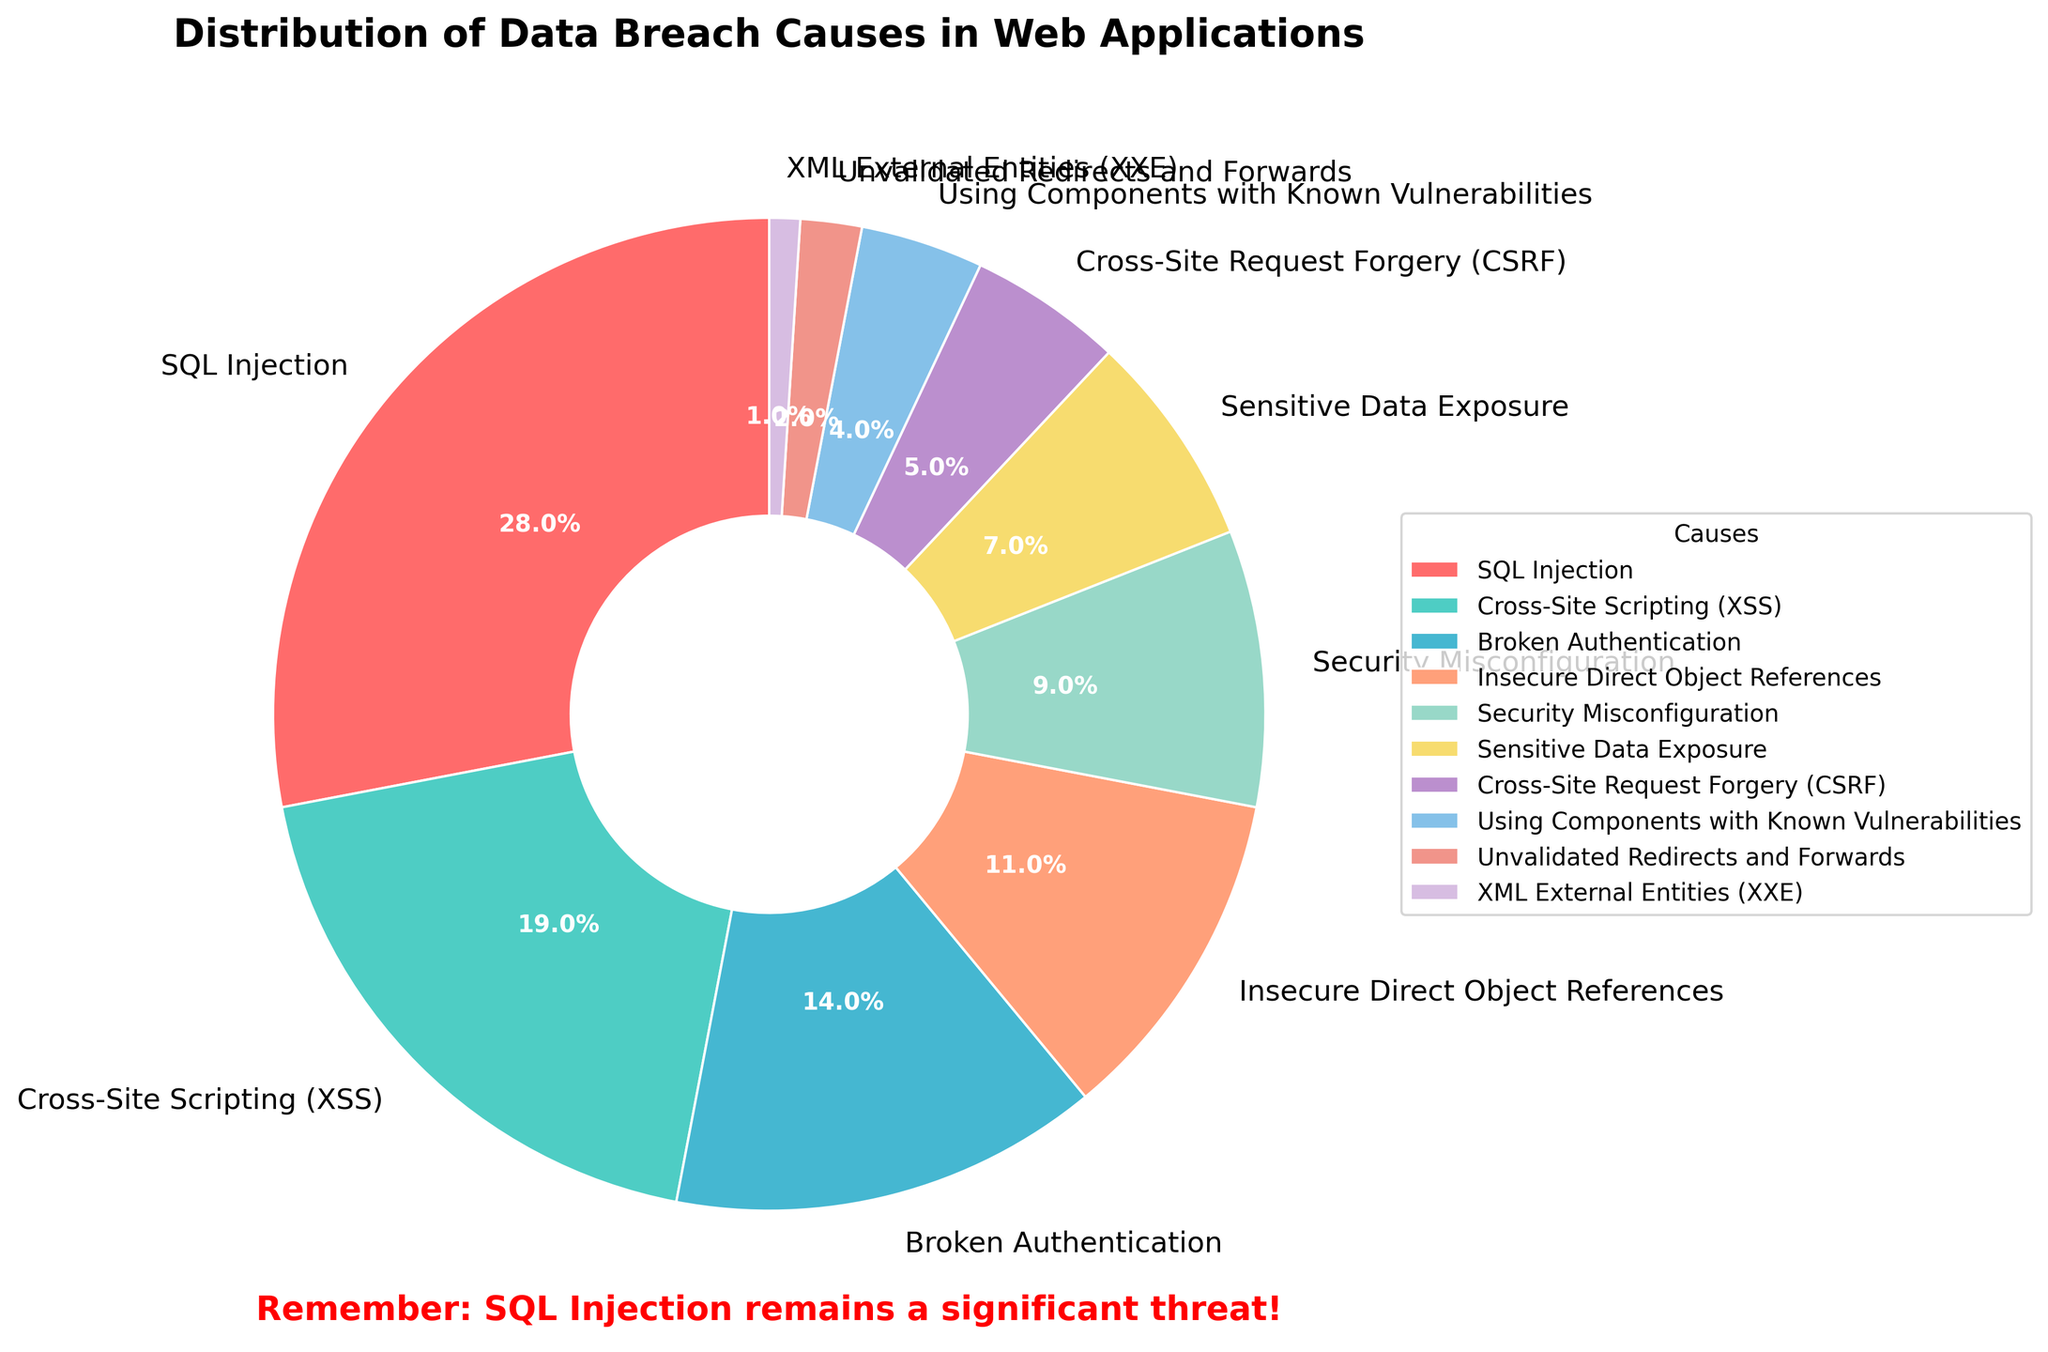Which cause has the largest percentage in the distribution? The pie chart shows the distribution of causes, and the largest wedge represents SQL Injection. The corresponding percentage is also displayed.
Answer: SQL Injection What is the combined percentage of Cross-Site Scripting (XSS) and Broken Authentication? To find the combined percentage, add the percentages of Cross-Site Scripting (19%) and Broken Authentication (14%).
Answer: 33% Rank the top three causes of data breaches. By comparing the sizes of the wedges and their percentages, the top three causes in descending order are SQL Injection (28%), Cross-Site Scripting (19%), and Broken Authentication (14%).
Answer: SQL Injection, Cross-Site Scripting, Broken Authentication How many causes have a percentage greater than or equal to 10%? Check each percentage and count the causes with values 10% or higher: SQL Injection (28%), Cross-Site Scripting (19%), Broken Authentication (14%), Insecure Direct Object References (11%).
Answer: 4 Which cause has the smallest percentage? The smallest wedge, labeled "XML External Entities (XXE)," has a percentage of 1%.
Answer: XML External Entities (XXE) What is the difference in percentage between Security Misconfiguration and Sensitive Data Exposure? Subtract the percentage of Sensitive Data Exposure (7%) from Security Misconfiguration (9%).
Answer: 2% Which causes have similar percentages? By examining the values, Sensitive Data Exposure (7%) and Cross-Site Request Forgery (CSRF) (5%) have close percentages.
Answer: Sensitive Data Exposure and Cross-Site Request Forgery If you sum up the percentages of Security Misconfiguration, Sensitive Data Exposure, and Cross-Site Request Forgery (CSRF), what is the total? Add the percentages: Security Misconfiguration (9%) + Sensitive Data Exposure (7%) + Cross-Site Request Forgery (CSRF) (5%).
Answer: 21% What colors represent SQL Injection and Cross-Site Scripting (XSS)? The pie chart uses specific colors for each cause. SQL Injection is represented by a red color, and Cross-Site Scripting (XSS) by a teal color.
Answer: Red and Teal How does the distribution emphasize the risk of SQL Injection? The pie chart includes a subtitle emphasizing the threat of SQL Injection, and SQL Injection has the largest wedge and percentage.
Answer: It highlights SQL Injection's dominance and additional text warning 